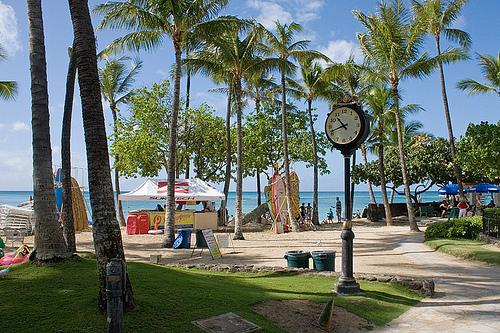These people are most likely on what type of event? vacation 